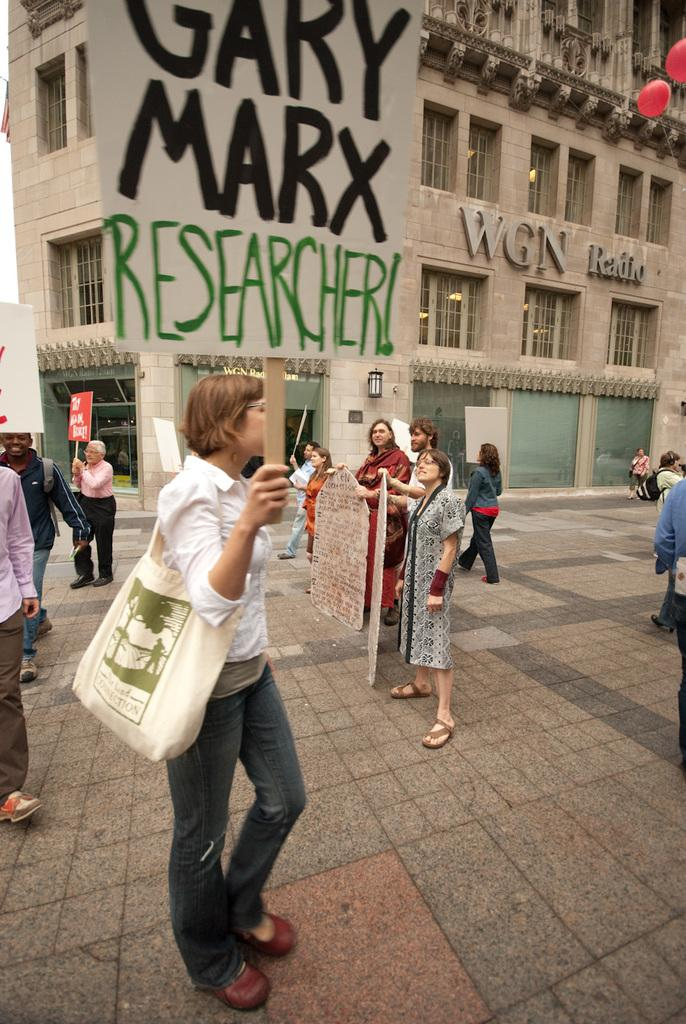What are the people in the image doing? The people in the image are standing on the road and holding pluck cards. What can be seen in the background of the image? There are buildings and balloons in the background of the image. What is the people's desire for the territory in the image? There is no mention of territory or desire in the image; it simply shows people standing on the road with pluck cards. 